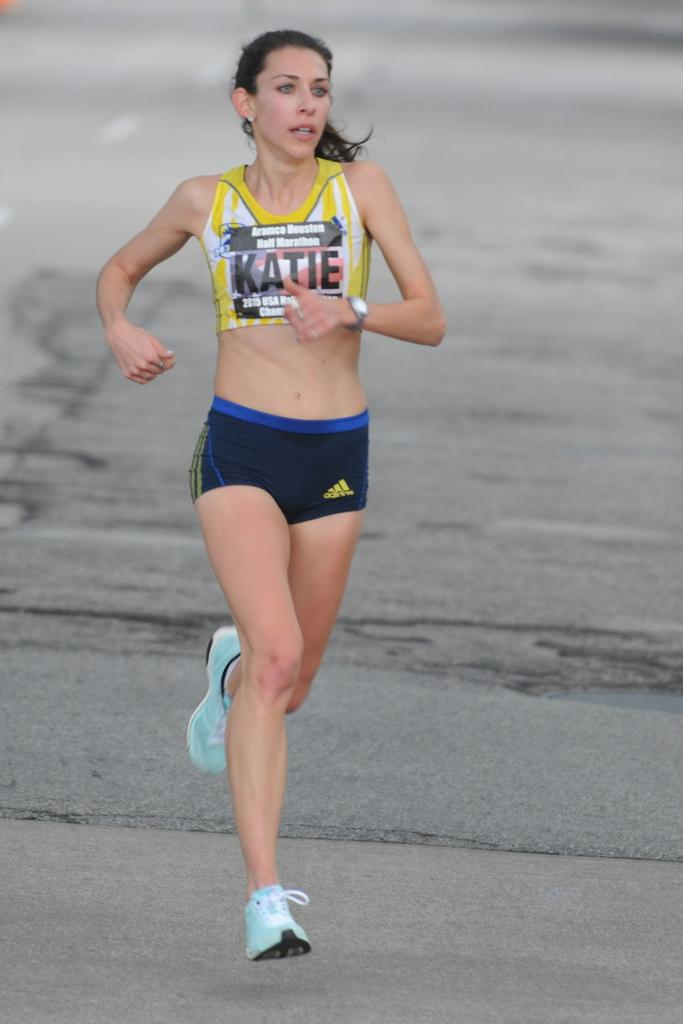Provide a one-sentence caption for the provided image. A woman athlete running on concrete for the Aramco Houston Half Marathon. 